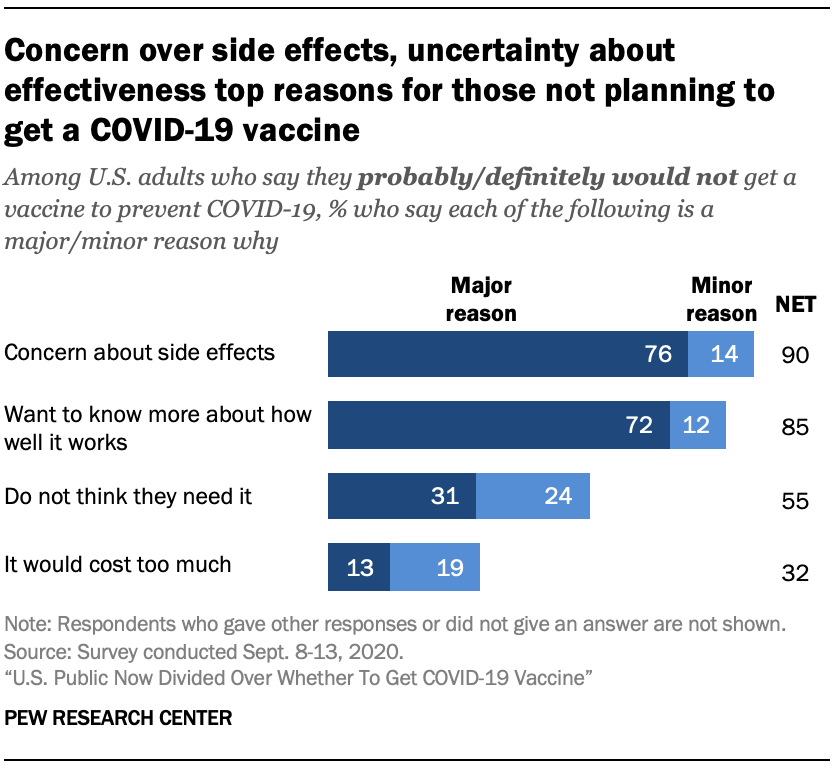Draw attention to some important aspects in this diagram. The value of navy blue for the phrase "It would cost too much" is 13. The median of all the values of the light blue bar is 16.5. 